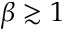<formula> <loc_0><loc_0><loc_500><loc_500>\beta \gtrsim 1</formula> 